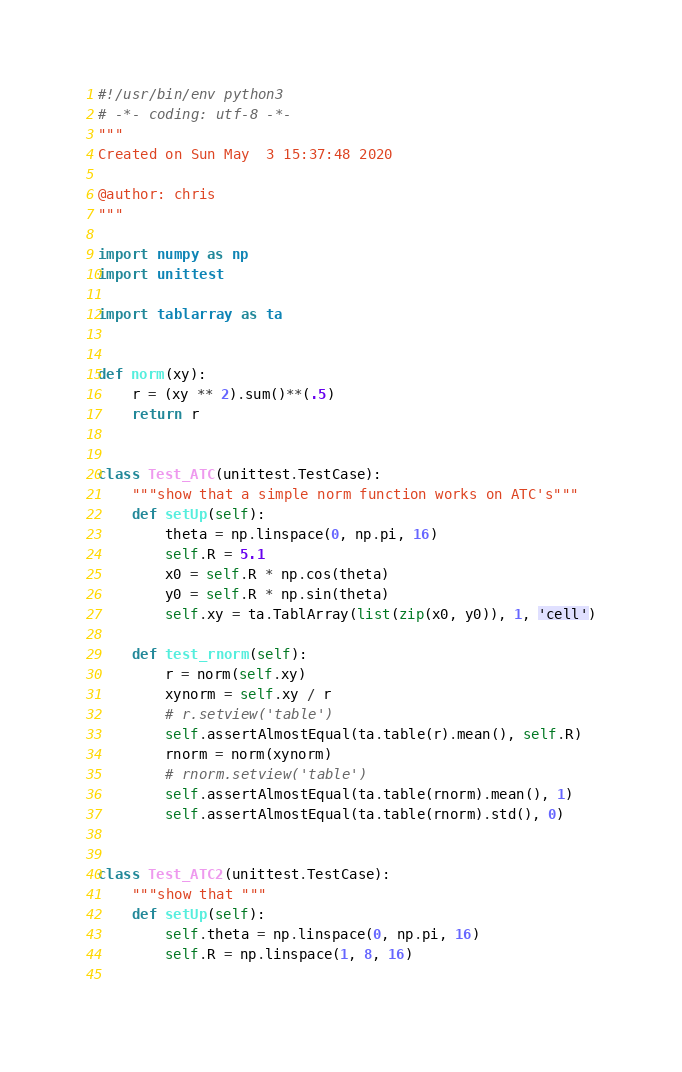<code> <loc_0><loc_0><loc_500><loc_500><_Python_>#!/usr/bin/env python3
# -*- coding: utf-8 -*-
"""
Created on Sun May  3 15:37:48 2020

@author: chris
"""

import numpy as np
import unittest

import tablarray as ta


def norm(xy):
    r = (xy ** 2).sum()**(.5)
    return r


class Test_ATC(unittest.TestCase):
    """show that a simple norm function works on ATC's"""
    def setUp(self):
        theta = np.linspace(0, np.pi, 16)
        self.R = 5.1
        x0 = self.R * np.cos(theta)
        y0 = self.R * np.sin(theta)
        self.xy = ta.TablArray(list(zip(x0, y0)), 1, 'cell')

    def test_rnorm(self):
        r = norm(self.xy)
        xynorm = self.xy / r
        # r.setview('table')
        self.assertAlmostEqual(ta.table(r).mean(), self.R)
        rnorm = norm(xynorm)
        # rnorm.setview('table')
        self.assertAlmostEqual(ta.table(rnorm).mean(), 1)
        self.assertAlmostEqual(ta.table(rnorm).std(), 0)


class Test_ATC2(unittest.TestCase):
    """show that """
    def setUp(self):
        self.theta = np.linspace(0, np.pi, 16)
        self.R = np.linspace(1, 8, 16)
        
</code> 